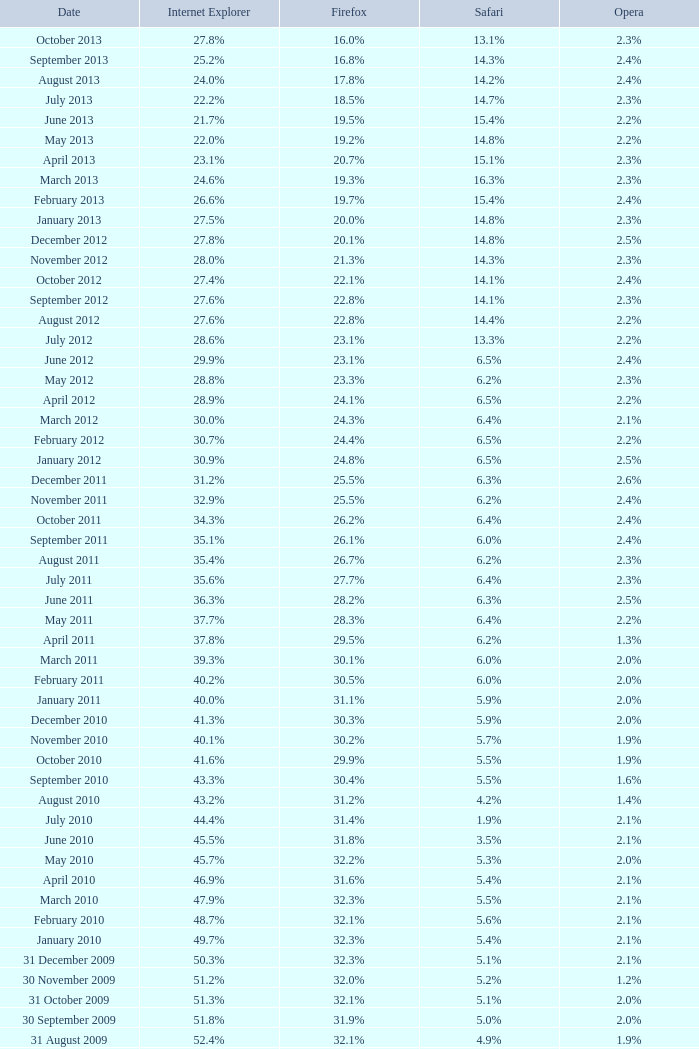How much is firefox's value when there's a 1.9% safari share? 31.4%. 